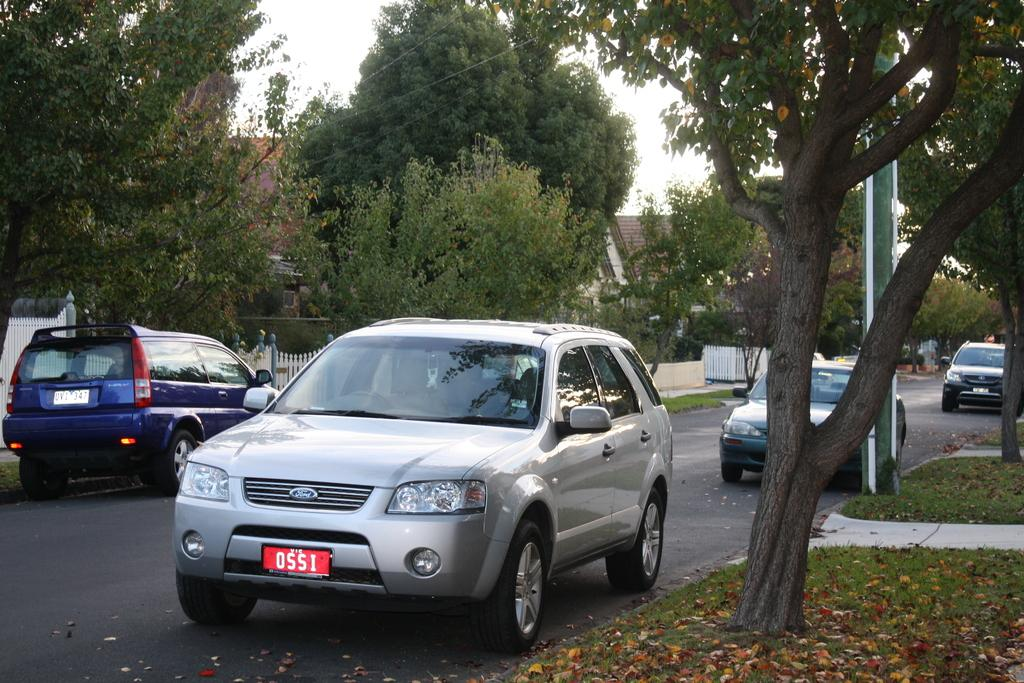What can be seen on the road in the image? There are motor vehicles on the road in the image. What is present on the ground in the image? Shredded leaves are present on the ground in the image. What type of natural elements are visible in the image? There are trees in the image. What type of man-made structures can be seen in the image? There are buildings in the image. What type of cooking equipment is visible in the image? Wooden grills are visible in the image. What part of the natural environment is visible in the image? The sky is visible in the image. What is the opinion of the trees about the motor vehicles on the road? Trees do not have opinions, as they are inanimate objects. 